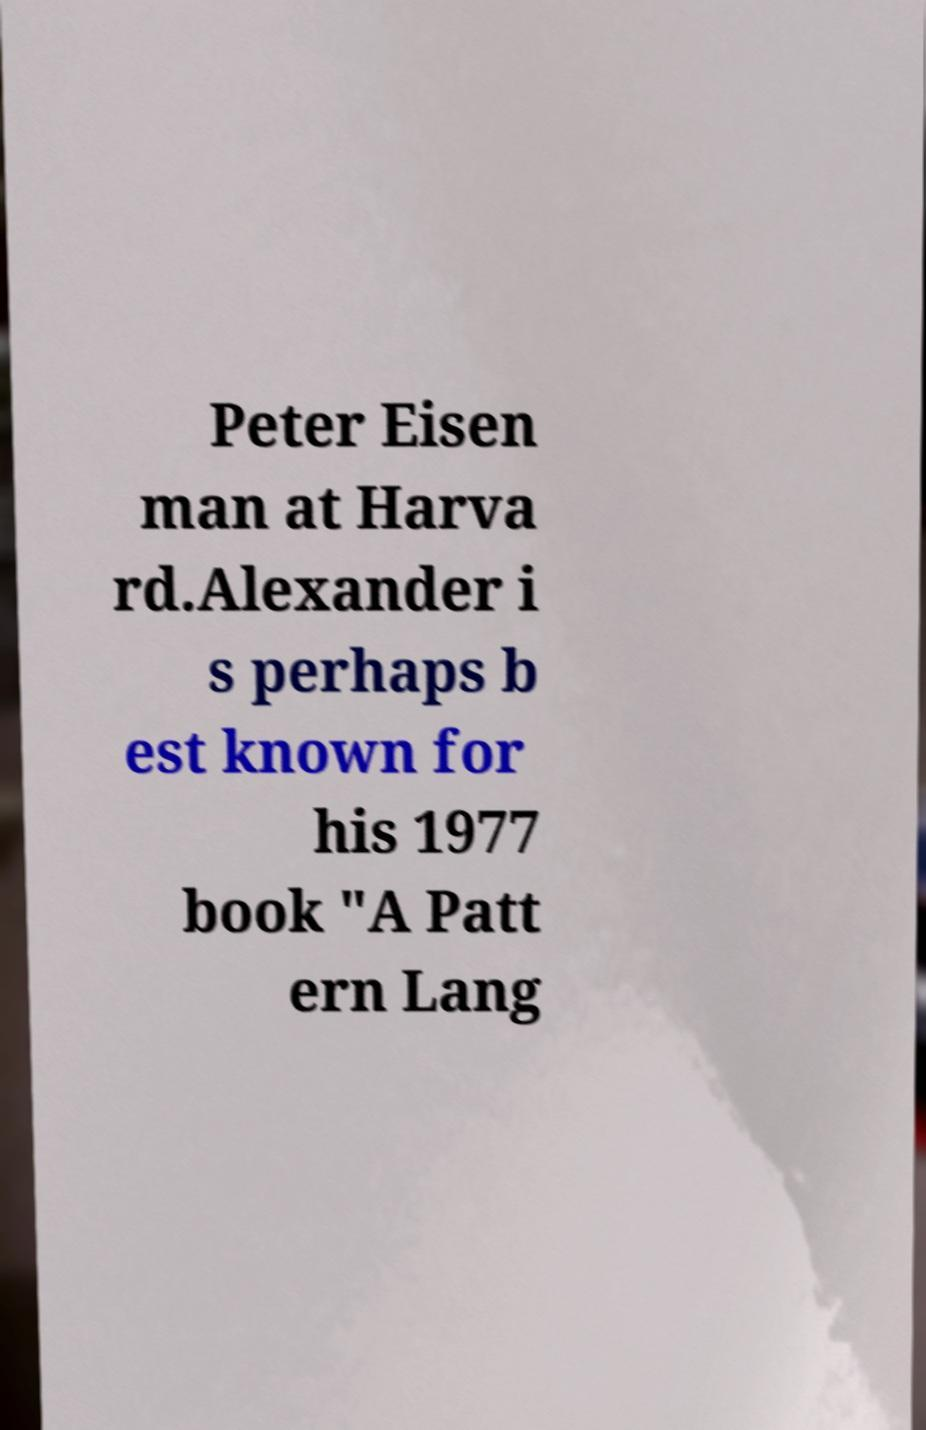Could you assist in decoding the text presented in this image and type it out clearly? Peter Eisen man at Harva rd.Alexander i s perhaps b est known for his 1977 book "A Patt ern Lang 